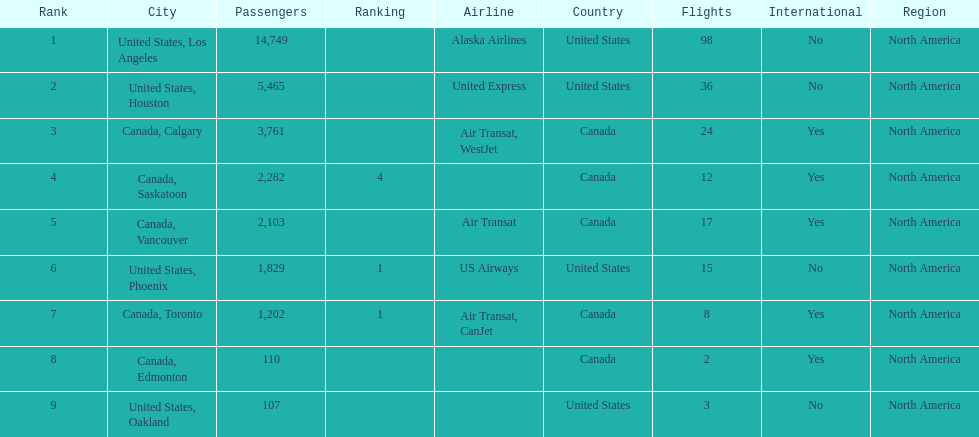Which airline carries the most passengers? Alaska Airlines. 